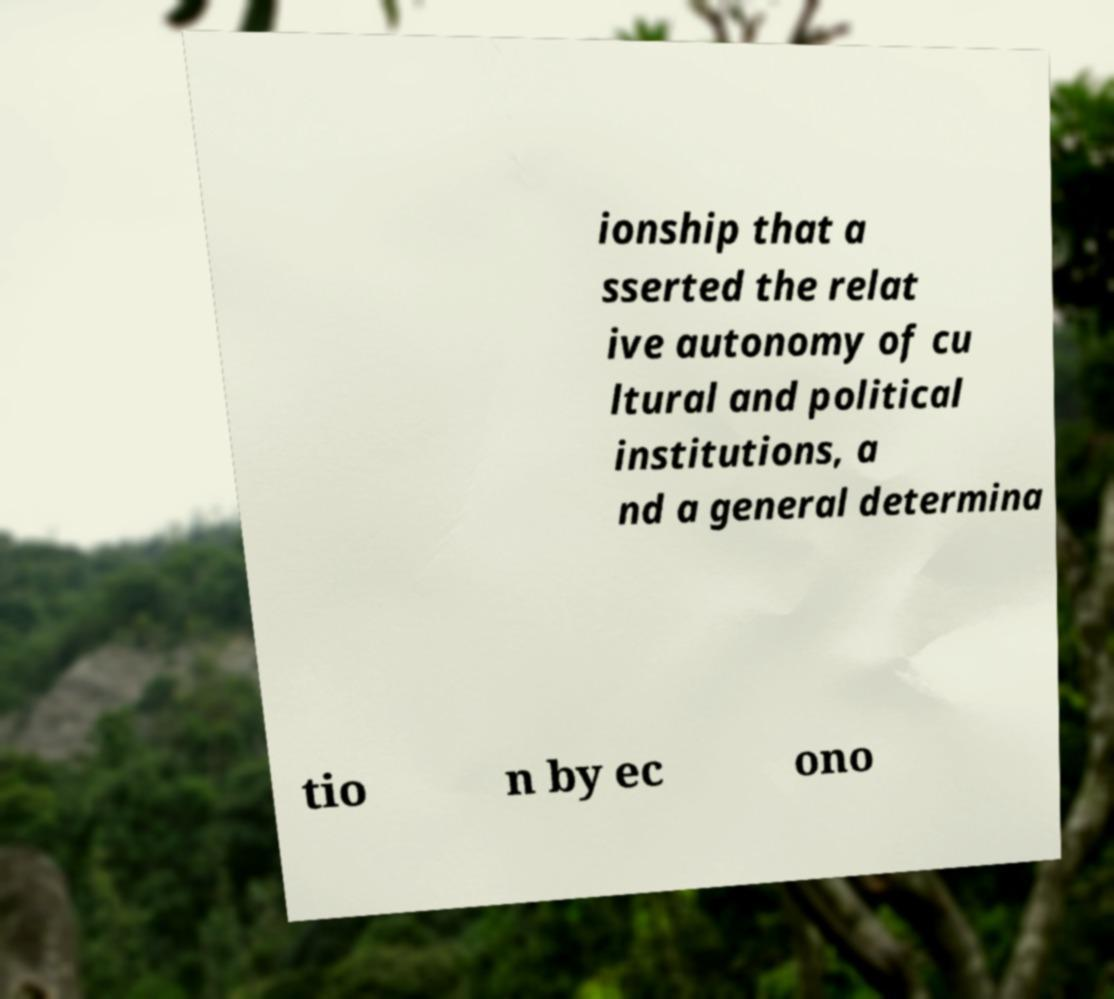There's text embedded in this image that I need extracted. Can you transcribe it verbatim? ionship that a sserted the relat ive autonomy of cu ltural and political institutions, a nd a general determina tio n by ec ono 